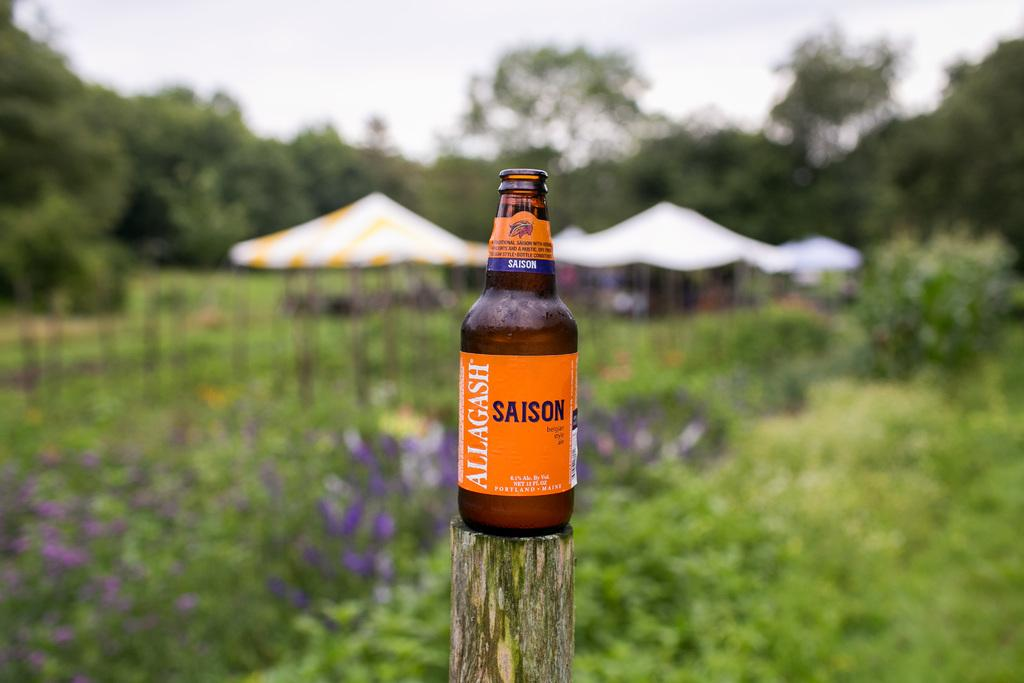What type of natural elements can be seen in the image? There are plants and trees in the image. What type of temporary shelters are visible in the image? There are tents in the image. What is attached to the pole in the image? There is a bottle on a pole in the image. What is the condition of the sky in the image? The sky is visible in the image and appears cloudy. How many brothers are depicted in the image? There are no brothers present in the image. What type of letters can be seen in the image? There are no letters visible in the image. 